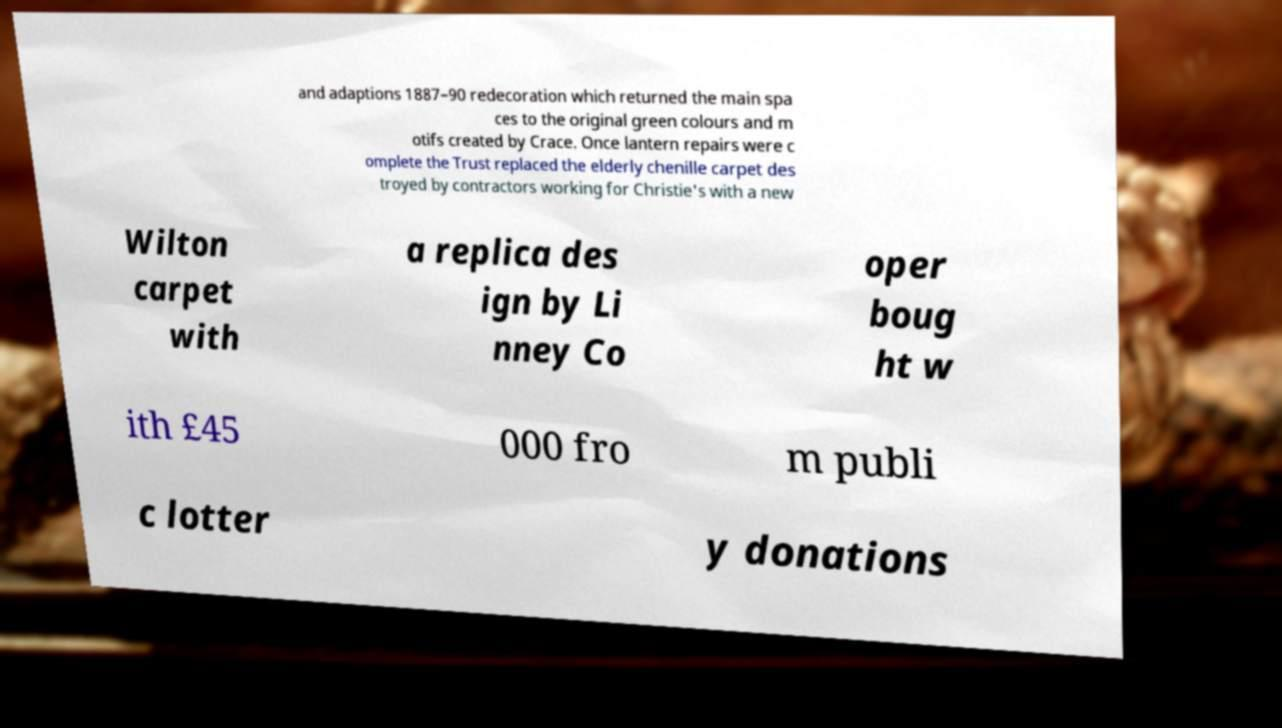What messages or text are displayed in this image? I need them in a readable, typed format. and adaptions 1887–90 redecoration which returned the main spa ces to the original green colours and m otifs created by Crace. Once lantern repairs were c omplete the Trust replaced the elderly chenille carpet des troyed by contractors working for Christie's with a new Wilton carpet with a replica des ign by Li nney Co oper boug ht w ith £45 000 fro m publi c lotter y donations 